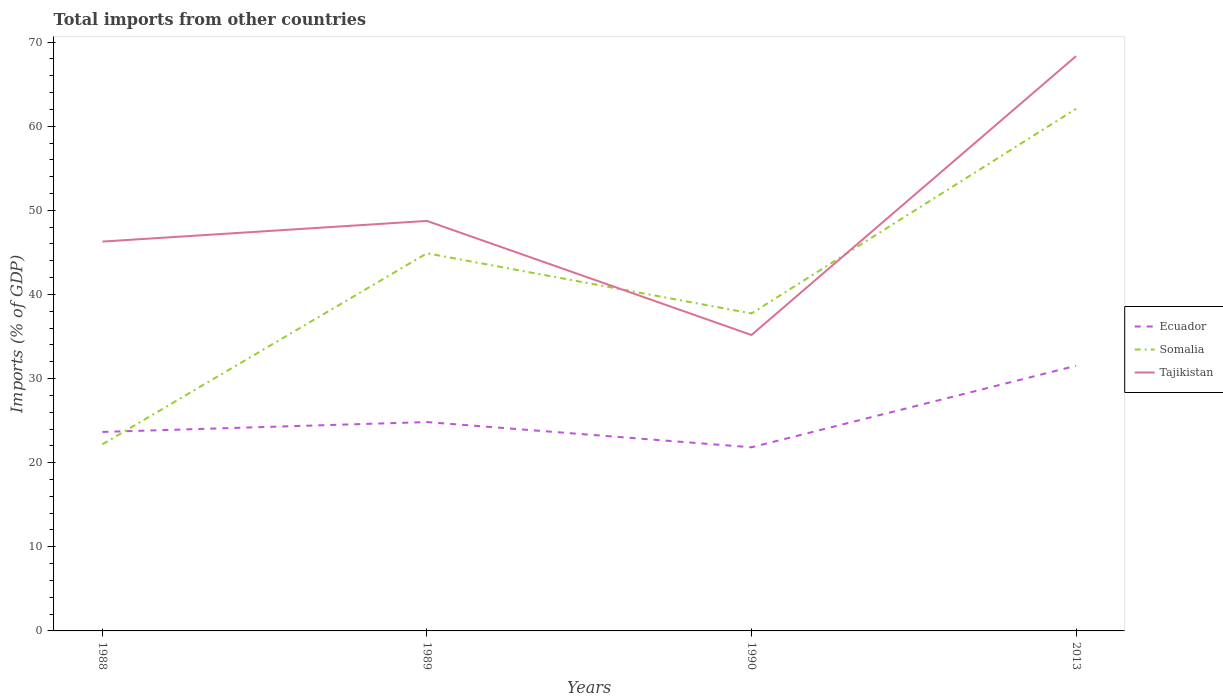Across all years, what is the maximum total imports in Somalia?
Offer a very short reply. 22.18. In which year was the total imports in Ecuador maximum?
Your answer should be compact. 1990. What is the total total imports in Ecuador in the graph?
Provide a short and direct response. -6.69. What is the difference between the highest and the second highest total imports in Ecuador?
Keep it short and to the point. 9.69. Is the total imports in Tajikistan strictly greater than the total imports in Somalia over the years?
Offer a very short reply. No. What is the difference between two consecutive major ticks on the Y-axis?
Offer a terse response. 10. Does the graph contain any zero values?
Offer a very short reply. No. Where does the legend appear in the graph?
Provide a succinct answer. Center right. How are the legend labels stacked?
Ensure brevity in your answer.  Vertical. What is the title of the graph?
Ensure brevity in your answer.  Total imports from other countries. Does "Uzbekistan" appear as one of the legend labels in the graph?
Your answer should be very brief. No. What is the label or title of the Y-axis?
Provide a succinct answer. Imports (% of GDP). What is the Imports (% of GDP) of Ecuador in 1988?
Keep it short and to the point. 23.66. What is the Imports (% of GDP) of Somalia in 1988?
Your answer should be compact. 22.18. What is the Imports (% of GDP) of Tajikistan in 1988?
Make the answer very short. 46.29. What is the Imports (% of GDP) in Ecuador in 1989?
Give a very brief answer. 24.83. What is the Imports (% of GDP) in Somalia in 1989?
Provide a succinct answer. 44.9. What is the Imports (% of GDP) of Tajikistan in 1989?
Offer a terse response. 48.74. What is the Imports (% of GDP) of Ecuador in 1990?
Keep it short and to the point. 21.83. What is the Imports (% of GDP) of Somalia in 1990?
Offer a very short reply. 37.74. What is the Imports (% of GDP) of Tajikistan in 1990?
Your response must be concise. 35.18. What is the Imports (% of GDP) of Ecuador in 2013?
Provide a short and direct response. 31.52. What is the Imports (% of GDP) in Somalia in 2013?
Provide a succinct answer. 62.07. What is the Imports (% of GDP) in Tajikistan in 2013?
Make the answer very short. 68.33. Across all years, what is the maximum Imports (% of GDP) of Ecuador?
Your response must be concise. 31.52. Across all years, what is the maximum Imports (% of GDP) of Somalia?
Make the answer very short. 62.07. Across all years, what is the maximum Imports (% of GDP) in Tajikistan?
Make the answer very short. 68.33. Across all years, what is the minimum Imports (% of GDP) in Ecuador?
Your answer should be very brief. 21.83. Across all years, what is the minimum Imports (% of GDP) in Somalia?
Give a very brief answer. 22.18. Across all years, what is the minimum Imports (% of GDP) in Tajikistan?
Provide a short and direct response. 35.18. What is the total Imports (% of GDP) in Ecuador in the graph?
Your answer should be very brief. 101.84. What is the total Imports (% of GDP) of Somalia in the graph?
Offer a very short reply. 166.89. What is the total Imports (% of GDP) of Tajikistan in the graph?
Keep it short and to the point. 198.54. What is the difference between the Imports (% of GDP) of Ecuador in 1988 and that in 1989?
Offer a terse response. -1.17. What is the difference between the Imports (% of GDP) in Somalia in 1988 and that in 1989?
Your answer should be very brief. -22.71. What is the difference between the Imports (% of GDP) in Tajikistan in 1988 and that in 1989?
Offer a terse response. -2.46. What is the difference between the Imports (% of GDP) of Ecuador in 1988 and that in 1990?
Your response must be concise. 1.83. What is the difference between the Imports (% of GDP) of Somalia in 1988 and that in 1990?
Make the answer very short. -15.56. What is the difference between the Imports (% of GDP) in Tajikistan in 1988 and that in 1990?
Offer a very short reply. 11.11. What is the difference between the Imports (% of GDP) in Ecuador in 1988 and that in 2013?
Offer a very short reply. -7.86. What is the difference between the Imports (% of GDP) of Somalia in 1988 and that in 2013?
Your answer should be very brief. -39.89. What is the difference between the Imports (% of GDP) of Tajikistan in 1988 and that in 2013?
Keep it short and to the point. -22.05. What is the difference between the Imports (% of GDP) of Ecuador in 1989 and that in 1990?
Make the answer very short. 3. What is the difference between the Imports (% of GDP) of Somalia in 1989 and that in 1990?
Offer a very short reply. 7.16. What is the difference between the Imports (% of GDP) in Tajikistan in 1989 and that in 1990?
Provide a short and direct response. 13.56. What is the difference between the Imports (% of GDP) of Ecuador in 1989 and that in 2013?
Your answer should be very brief. -6.69. What is the difference between the Imports (% of GDP) of Somalia in 1989 and that in 2013?
Your answer should be compact. -17.17. What is the difference between the Imports (% of GDP) in Tajikistan in 1989 and that in 2013?
Ensure brevity in your answer.  -19.59. What is the difference between the Imports (% of GDP) in Ecuador in 1990 and that in 2013?
Make the answer very short. -9.69. What is the difference between the Imports (% of GDP) in Somalia in 1990 and that in 2013?
Ensure brevity in your answer.  -24.33. What is the difference between the Imports (% of GDP) in Tajikistan in 1990 and that in 2013?
Keep it short and to the point. -33.15. What is the difference between the Imports (% of GDP) of Ecuador in 1988 and the Imports (% of GDP) of Somalia in 1989?
Make the answer very short. -21.24. What is the difference between the Imports (% of GDP) of Ecuador in 1988 and the Imports (% of GDP) of Tajikistan in 1989?
Keep it short and to the point. -25.09. What is the difference between the Imports (% of GDP) of Somalia in 1988 and the Imports (% of GDP) of Tajikistan in 1989?
Offer a terse response. -26.56. What is the difference between the Imports (% of GDP) in Ecuador in 1988 and the Imports (% of GDP) in Somalia in 1990?
Keep it short and to the point. -14.09. What is the difference between the Imports (% of GDP) in Ecuador in 1988 and the Imports (% of GDP) in Tajikistan in 1990?
Offer a terse response. -11.52. What is the difference between the Imports (% of GDP) of Somalia in 1988 and the Imports (% of GDP) of Tajikistan in 1990?
Give a very brief answer. -13. What is the difference between the Imports (% of GDP) of Ecuador in 1988 and the Imports (% of GDP) of Somalia in 2013?
Make the answer very short. -38.41. What is the difference between the Imports (% of GDP) in Ecuador in 1988 and the Imports (% of GDP) in Tajikistan in 2013?
Give a very brief answer. -44.68. What is the difference between the Imports (% of GDP) in Somalia in 1988 and the Imports (% of GDP) in Tajikistan in 2013?
Offer a very short reply. -46.15. What is the difference between the Imports (% of GDP) of Ecuador in 1989 and the Imports (% of GDP) of Somalia in 1990?
Ensure brevity in your answer.  -12.91. What is the difference between the Imports (% of GDP) of Ecuador in 1989 and the Imports (% of GDP) of Tajikistan in 1990?
Provide a short and direct response. -10.35. What is the difference between the Imports (% of GDP) of Somalia in 1989 and the Imports (% of GDP) of Tajikistan in 1990?
Offer a terse response. 9.72. What is the difference between the Imports (% of GDP) of Ecuador in 1989 and the Imports (% of GDP) of Somalia in 2013?
Provide a short and direct response. -37.24. What is the difference between the Imports (% of GDP) of Ecuador in 1989 and the Imports (% of GDP) of Tajikistan in 2013?
Your answer should be compact. -43.5. What is the difference between the Imports (% of GDP) of Somalia in 1989 and the Imports (% of GDP) of Tajikistan in 2013?
Offer a terse response. -23.44. What is the difference between the Imports (% of GDP) of Ecuador in 1990 and the Imports (% of GDP) of Somalia in 2013?
Give a very brief answer. -40.24. What is the difference between the Imports (% of GDP) in Ecuador in 1990 and the Imports (% of GDP) in Tajikistan in 2013?
Ensure brevity in your answer.  -46.5. What is the difference between the Imports (% of GDP) in Somalia in 1990 and the Imports (% of GDP) in Tajikistan in 2013?
Offer a very short reply. -30.59. What is the average Imports (% of GDP) in Ecuador per year?
Keep it short and to the point. 25.46. What is the average Imports (% of GDP) in Somalia per year?
Offer a very short reply. 41.72. What is the average Imports (% of GDP) in Tajikistan per year?
Provide a succinct answer. 49.64. In the year 1988, what is the difference between the Imports (% of GDP) of Ecuador and Imports (% of GDP) of Somalia?
Provide a succinct answer. 1.47. In the year 1988, what is the difference between the Imports (% of GDP) in Ecuador and Imports (% of GDP) in Tajikistan?
Provide a succinct answer. -22.63. In the year 1988, what is the difference between the Imports (% of GDP) in Somalia and Imports (% of GDP) in Tajikistan?
Keep it short and to the point. -24.1. In the year 1989, what is the difference between the Imports (% of GDP) of Ecuador and Imports (% of GDP) of Somalia?
Provide a short and direct response. -20.07. In the year 1989, what is the difference between the Imports (% of GDP) in Ecuador and Imports (% of GDP) in Tajikistan?
Provide a succinct answer. -23.91. In the year 1989, what is the difference between the Imports (% of GDP) of Somalia and Imports (% of GDP) of Tajikistan?
Make the answer very short. -3.85. In the year 1990, what is the difference between the Imports (% of GDP) of Ecuador and Imports (% of GDP) of Somalia?
Offer a very short reply. -15.91. In the year 1990, what is the difference between the Imports (% of GDP) of Ecuador and Imports (% of GDP) of Tajikistan?
Ensure brevity in your answer.  -13.35. In the year 1990, what is the difference between the Imports (% of GDP) of Somalia and Imports (% of GDP) of Tajikistan?
Make the answer very short. 2.56. In the year 2013, what is the difference between the Imports (% of GDP) in Ecuador and Imports (% of GDP) in Somalia?
Provide a short and direct response. -30.55. In the year 2013, what is the difference between the Imports (% of GDP) in Ecuador and Imports (% of GDP) in Tajikistan?
Your answer should be very brief. -36.81. In the year 2013, what is the difference between the Imports (% of GDP) in Somalia and Imports (% of GDP) in Tajikistan?
Offer a very short reply. -6.26. What is the ratio of the Imports (% of GDP) of Ecuador in 1988 to that in 1989?
Give a very brief answer. 0.95. What is the ratio of the Imports (% of GDP) in Somalia in 1988 to that in 1989?
Your response must be concise. 0.49. What is the ratio of the Imports (% of GDP) in Tajikistan in 1988 to that in 1989?
Give a very brief answer. 0.95. What is the ratio of the Imports (% of GDP) in Ecuador in 1988 to that in 1990?
Offer a very short reply. 1.08. What is the ratio of the Imports (% of GDP) of Somalia in 1988 to that in 1990?
Give a very brief answer. 0.59. What is the ratio of the Imports (% of GDP) of Tajikistan in 1988 to that in 1990?
Keep it short and to the point. 1.32. What is the ratio of the Imports (% of GDP) of Ecuador in 1988 to that in 2013?
Offer a very short reply. 0.75. What is the ratio of the Imports (% of GDP) of Somalia in 1988 to that in 2013?
Your answer should be compact. 0.36. What is the ratio of the Imports (% of GDP) of Tajikistan in 1988 to that in 2013?
Offer a very short reply. 0.68. What is the ratio of the Imports (% of GDP) of Ecuador in 1989 to that in 1990?
Your response must be concise. 1.14. What is the ratio of the Imports (% of GDP) of Somalia in 1989 to that in 1990?
Keep it short and to the point. 1.19. What is the ratio of the Imports (% of GDP) of Tajikistan in 1989 to that in 1990?
Offer a terse response. 1.39. What is the ratio of the Imports (% of GDP) in Ecuador in 1989 to that in 2013?
Provide a succinct answer. 0.79. What is the ratio of the Imports (% of GDP) of Somalia in 1989 to that in 2013?
Provide a succinct answer. 0.72. What is the ratio of the Imports (% of GDP) of Tajikistan in 1989 to that in 2013?
Keep it short and to the point. 0.71. What is the ratio of the Imports (% of GDP) of Ecuador in 1990 to that in 2013?
Provide a short and direct response. 0.69. What is the ratio of the Imports (% of GDP) of Somalia in 1990 to that in 2013?
Provide a succinct answer. 0.61. What is the ratio of the Imports (% of GDP) in Tajikistan in 1990 to that in 2013?
Keep it short and to the point. 0.51. What is the difference between the highest and the second highest Imports (% of GDP) of Ecuador?
Make the answer very short. 6.69. What is the difference between the highest and the second highest Imports (% of GDP) of Somalia?
Provide a short and direct response. 17.17. What is the difference between the highest and the second highest Imports (% of GDP) in Tajikistan?
Your answer should be compact. 19.59. What is the difference between the highest and the lowest Imports (% of GDP) in Ecuador?
Provide a short and direct response. 9.69. What is the difference between the highest and the lowest Imports (% of GDP) in Somalia?
Ensure brevity in your answer.  39.89. What is the difference between the highest and the lowest Imports (% of GDP) of Tajikistan?
Provide a succinct answer. 33.15. 